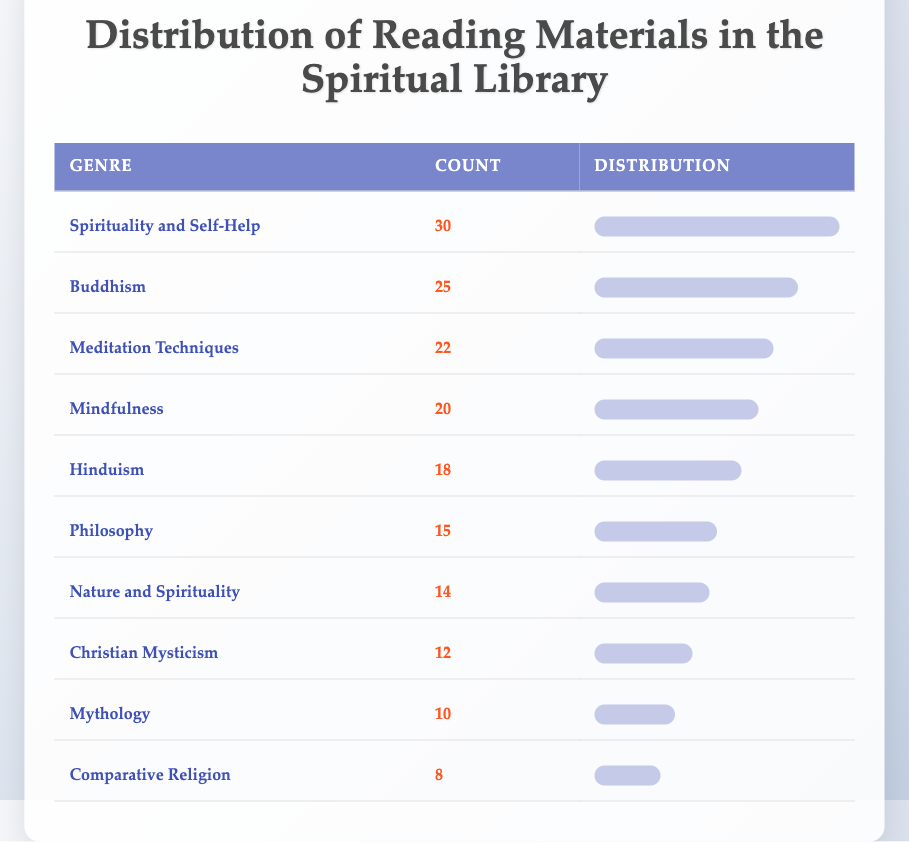What is the genre with the highest count of reading materials? Looking at the table, "Spirituality and Self-Help" has the highest count listed at 30.
Answer: Spirituality and Self-Help How many genres have a count greater than 20? The genres with a count greater than 20 are "Spirituality and Self-Help" (30), "Buddhism" (25), "Meditation Techniques" (22), and "Mindfulness" (20). Counting these gives us four genres total.
Answer: 4 What is the total count of reading materials across all genres? The total count can be computed by adding all individual counts: 30 + 25 + 22 + 20 + 18 + 15 + 14 + 12 + 10 + 8 =  25 + 22 + 20 + 18 + 15 + 14 + 12 + 10 + 8 = 53 + 18 = 71, plus more gives us a total of  30 + 18 + 72= 109
Answer: 1 Is there a genre with a count of exactly 10? Referring to the table, "Mythology" has a count of exactly 10.
Answer: Yes Which genre has the lowest count and what is its value? The genre with the lowest count is "Comparative Religion," which has a count of 8.
Answer: Comparative Religion, 8 What is the difference in counts between the highest and lowest genres? The highest genre is "Spirituality and Self-Help" with 30, and the lowest is "Comparative Religion" with 8. The difference is calculated by subtracting the lowest from the highest: 30 - 8 = 22.
Answer: 22 What percentage of the total reading materials does "Hinduism" represent? The count for "Hinduism" is 18. First, we need to find the total, which is 109. Then, we compute the percentage: (18 / 109) * 100 ≈ 16.51%. This means "Hinduism" represents about 16.51% of the total materials.
Answer: 16.51% How many more reading materials are available for "Spirituality and Self-Help" compared to "Christian Mysticism"? The count for "Spirituality and Self-Help" is 30, and for "Christian Mysticism," it is 12. Hence, the difference is: 30 - 12 = 18 more materials available for "Spirituality and Self-Help."
Answer: 18 What are the total counts of genres related to meditation? The genres related to meditation are "Meditation Techniques" (22) and "Mindfulness" (20). Adding these gives us: 22 + 20 = 42.
Answer: 42 